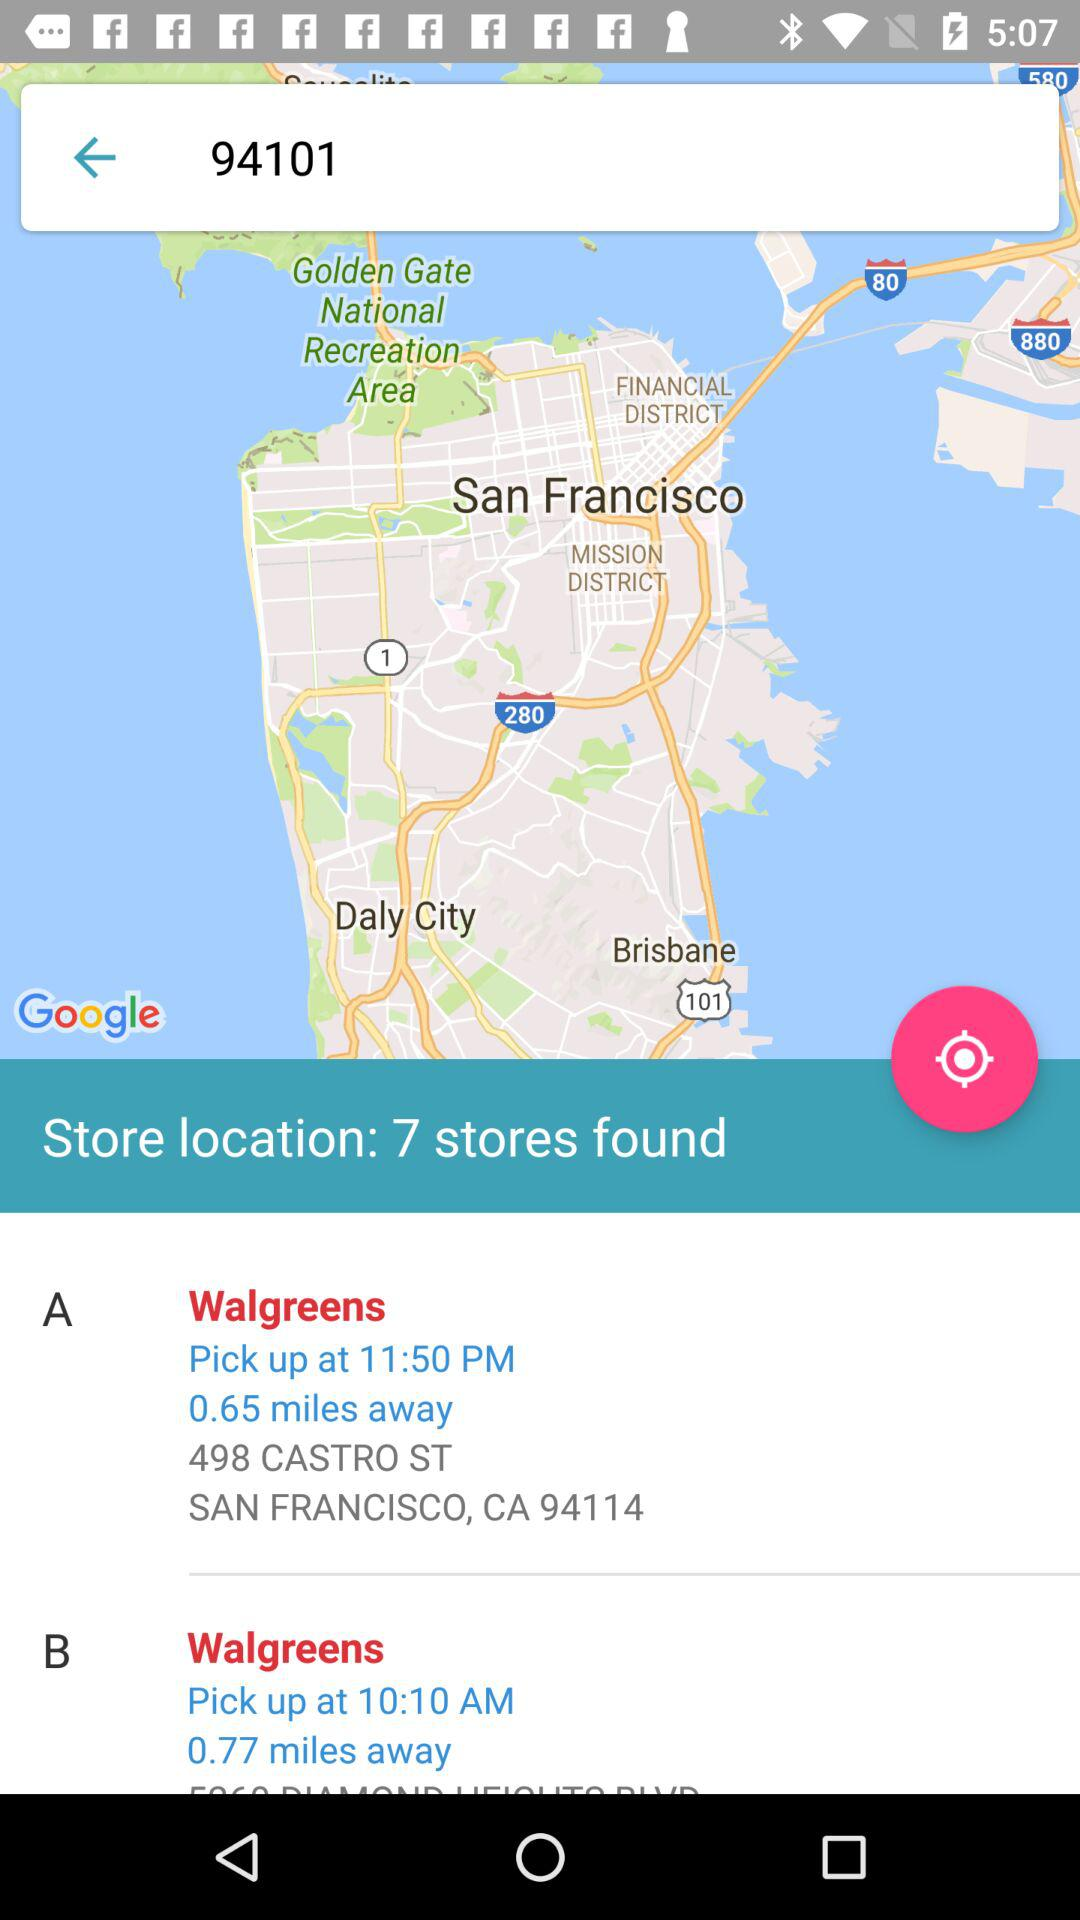What is the location of Walgreens-A? The location is "498 CASTRO ST, SAN FRANCISCO, CA 94114". 